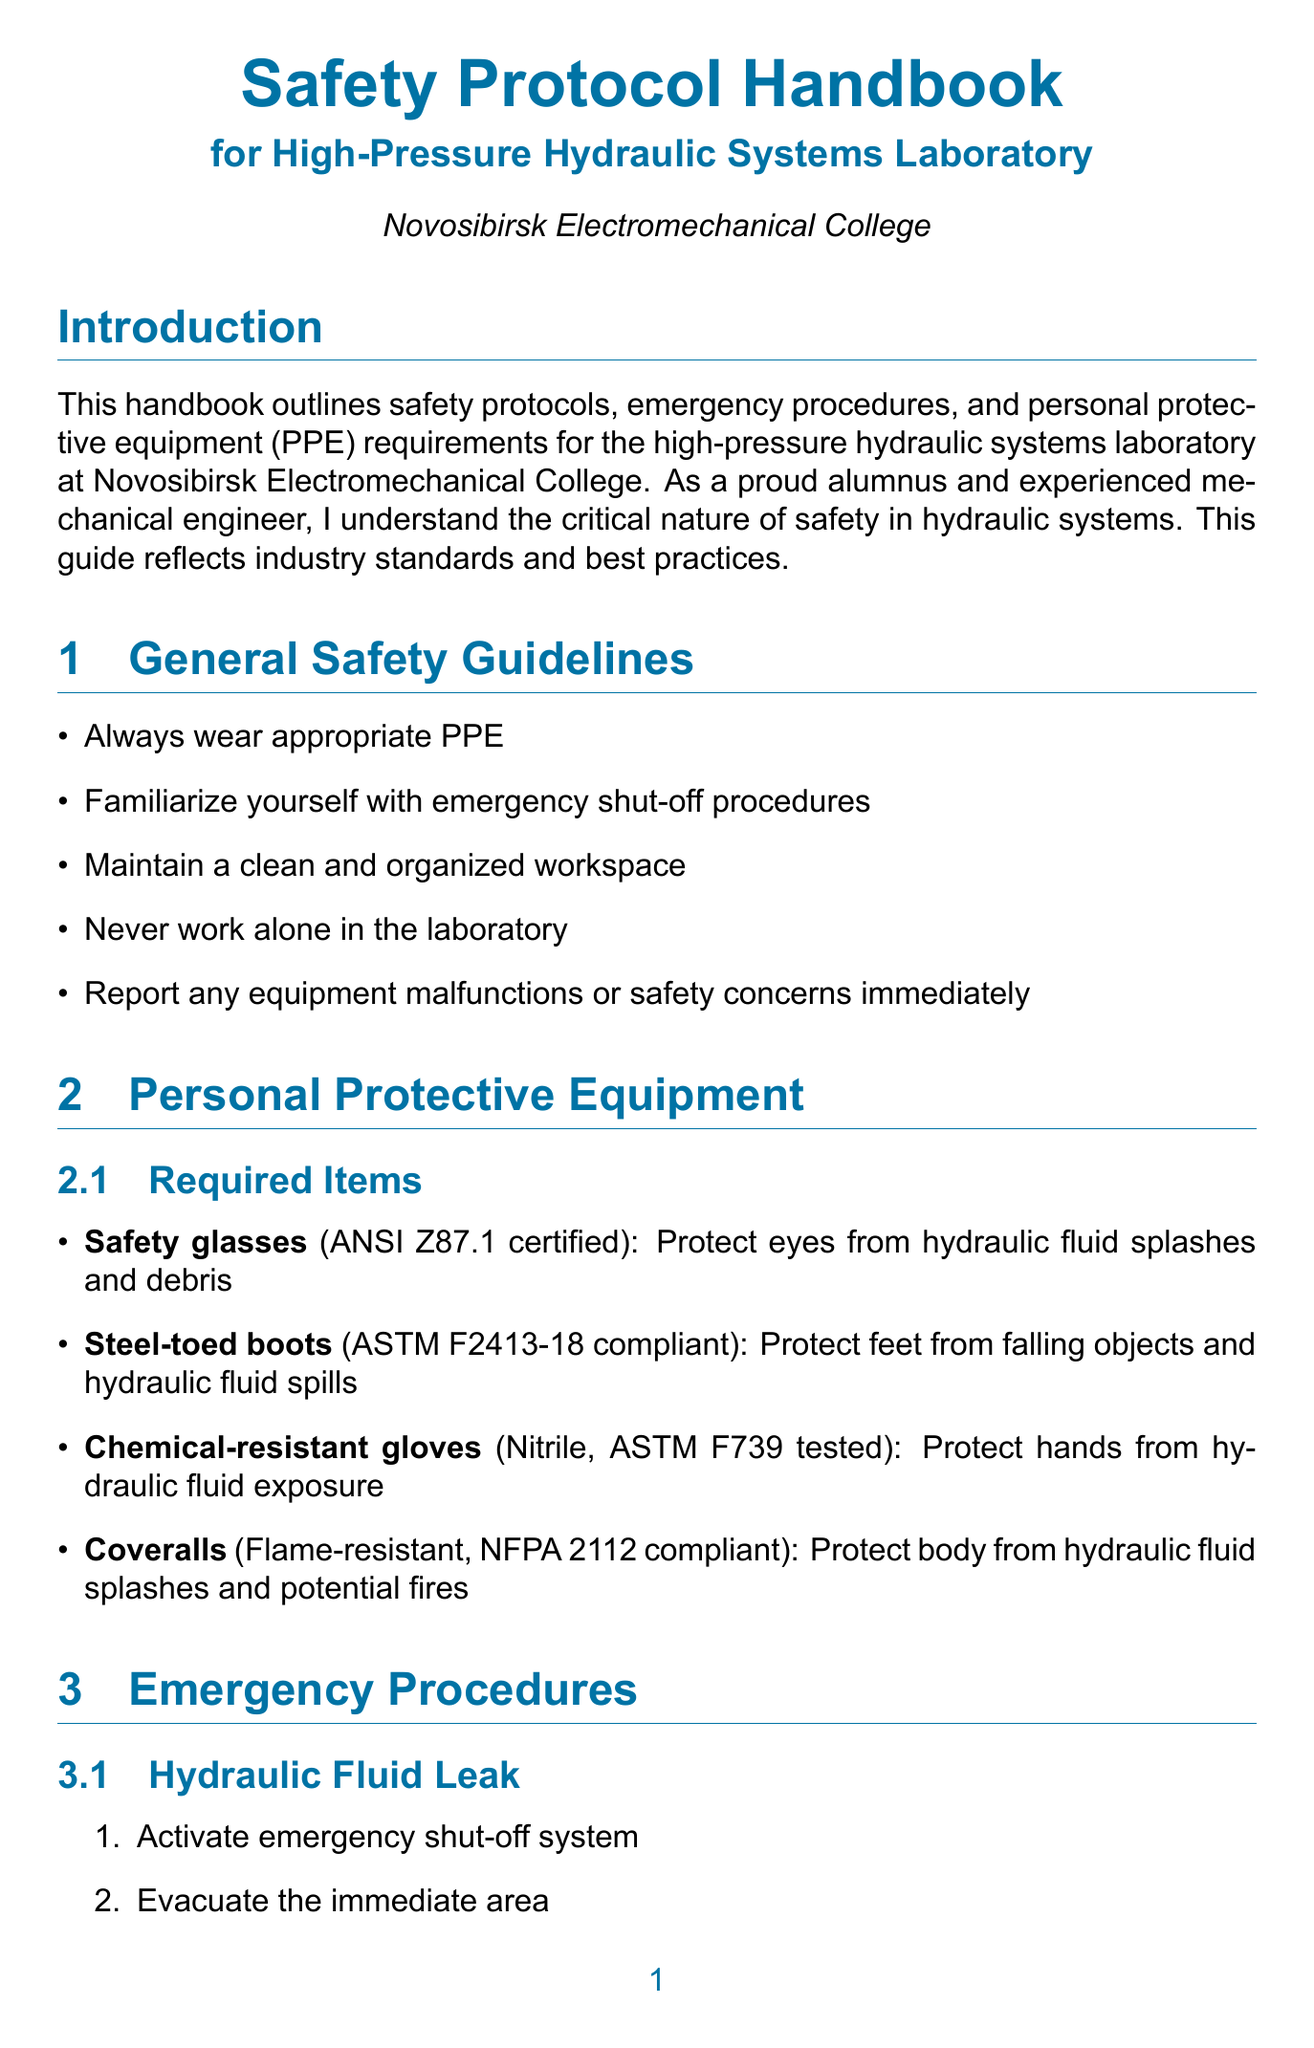what is the purpose of the handbook? The purpose of the handbook is outlined in the introduction, stating it provides safety protocols, emergency procedures, and personal protective equipment requirements for the laboratory.
Answer: safety protocols, emergency procedures, and personal protective equipment requirements who is the laboratory supervisor? The laboratory supervisor's name is mentioned in the contact information section of the document.
Answer: Dr. Alexei Petrov what is the maximum pressure for the high-pressure pump? This information is specified under the equipment-specific procedures section for the high-pressure pump.
Answer: 350 bar what should you do during a hydraulic fluid leak? The emergency procedures section details specific actions to take when there is a hydraulic fluid leak.
Answer: Activate emergency shut-off system what type of gloves are required? The personal protective equipment section specifies the type of gloves required for protection.
Answer: Chemical-resistant gloves how often should safety documentation be reviewed and updated? This is mentioned in the monthly procedures part of the maintenance and inspection section.
Answer: Monthly what are the training requirements for initial training? Key aspects of the training requirements are outlined, listing topics covered in initial training.
Answer: Laboratory safety orientation, hydraulic systems fundamentals, PPE usage and maintenance, emergency response procedures what is the capacity of the hydraulic press? The capacity of the hydraulic press is listed under its equipment-specific procedures section.
Answer: 100 tons who to contact in case of an emergency? The contact information section specifies the emergency services number.
Answer: 112 